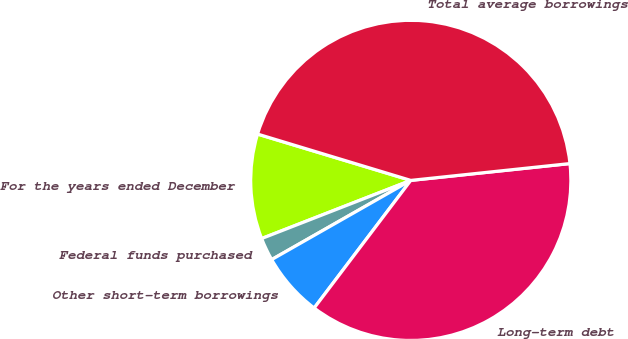<chart> <loc_0><loc_0><loc_500><loc_500><pie_chart><fcel>For the years ended December<fcel>Federal funds purchased<fcel>Other short-term borrowings<fcel>Long-term debt<fcel>Total average borrowings<nl><fcel>10.59%<fcel>2.32%<fcel>6.45%<fcel>36.99%<fcel>43.65%<nl></chart> 